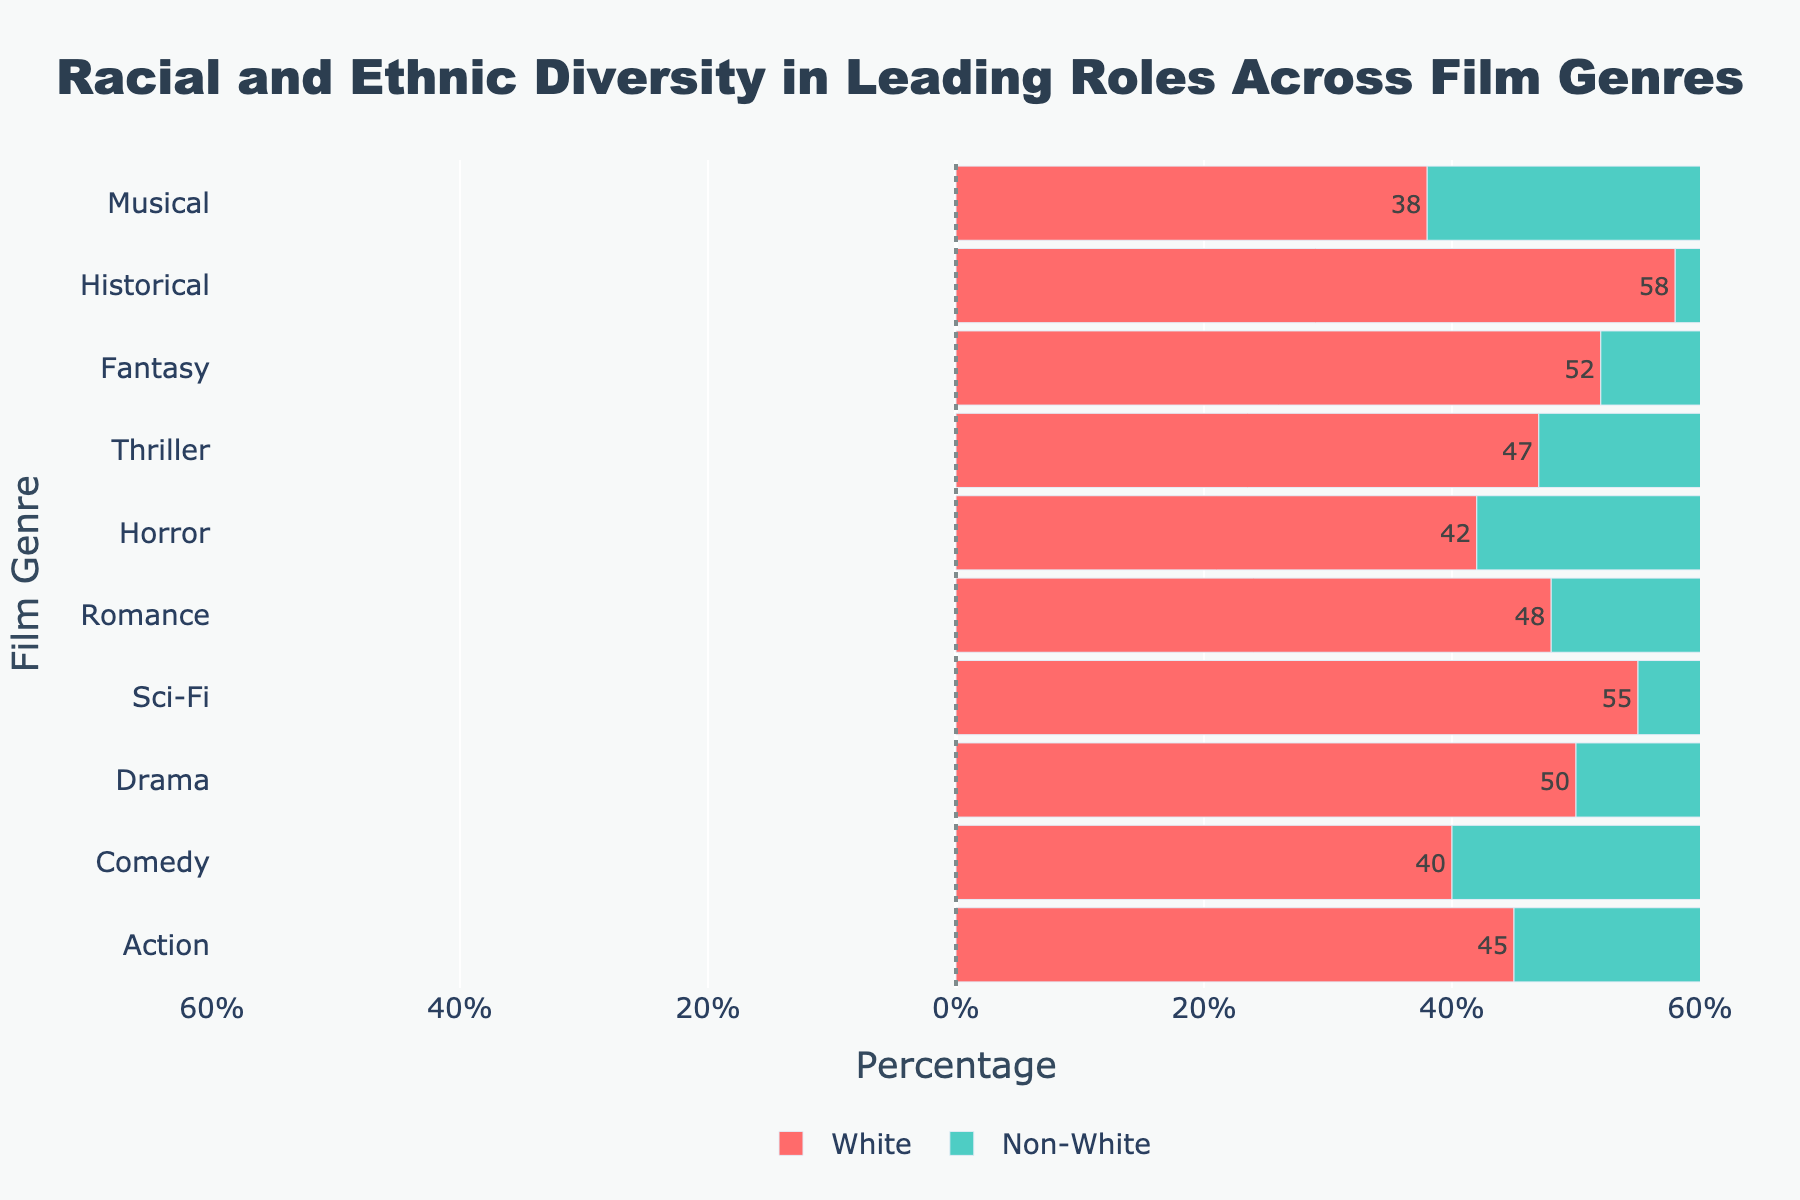what is the genre with the lowest percentage of Non-White leading roles? The figure shows the percentage of Non-White leading roles across different film genres. The genre with the lowest percentage has the smallest positive bar in the Non-White section.
Answer: Historical Which genre has the highest percentage of White leading roles? From the figure, identify the genre with the longest negative bar in the White section.
Answer: Historical What is the difference between the percentage of White and Non-White leading roles in Comedy? Locate the Comedy genre and compare the bar lengths for White (negative) and Non-White (positive). Subtract the Non-White value from the absolute White value.
Answer: 10 How many genres have a Non-White leading roles percentage higher than 30%? Count the number of Non-White bars that have lengths greater than 30% of the total axis length.
Answer: 2 What is the percentage of White leading roles in Musical? Refer to the Musical genre and note the length of the negative bar corresponding to White.
Answer: 38 Which genre has a closer balance between White and Non-White leading roles percentages? Look for the genre where the lengths of the negative (White) and positive (Non-White) bars are the most similar.
Answer: Comedy Which genre has the second-highest percentage of Non-White leading roles? Identify the Non-White genre with the second-longest positive bar.
Answer: Comedy What is the total percentage of both White and Non-White leading roles in Sci-Fi? Add the absolute percentage of White leading roles to the percentage of Non-White leading roles in Sci-Fi.
Answer: 75% Which genre has fewer Non-White leading roles, Romance or Fantasy? Compare the lengths of the positive bars for Non-White leading roles in Romance and Fantasy.
Answer: Fantasy Across all genres, what is the average percentage of White leading roles? Sum the percentages of White leading roles across all genres and divide by the number of genres (10).
Answer: 47.5 